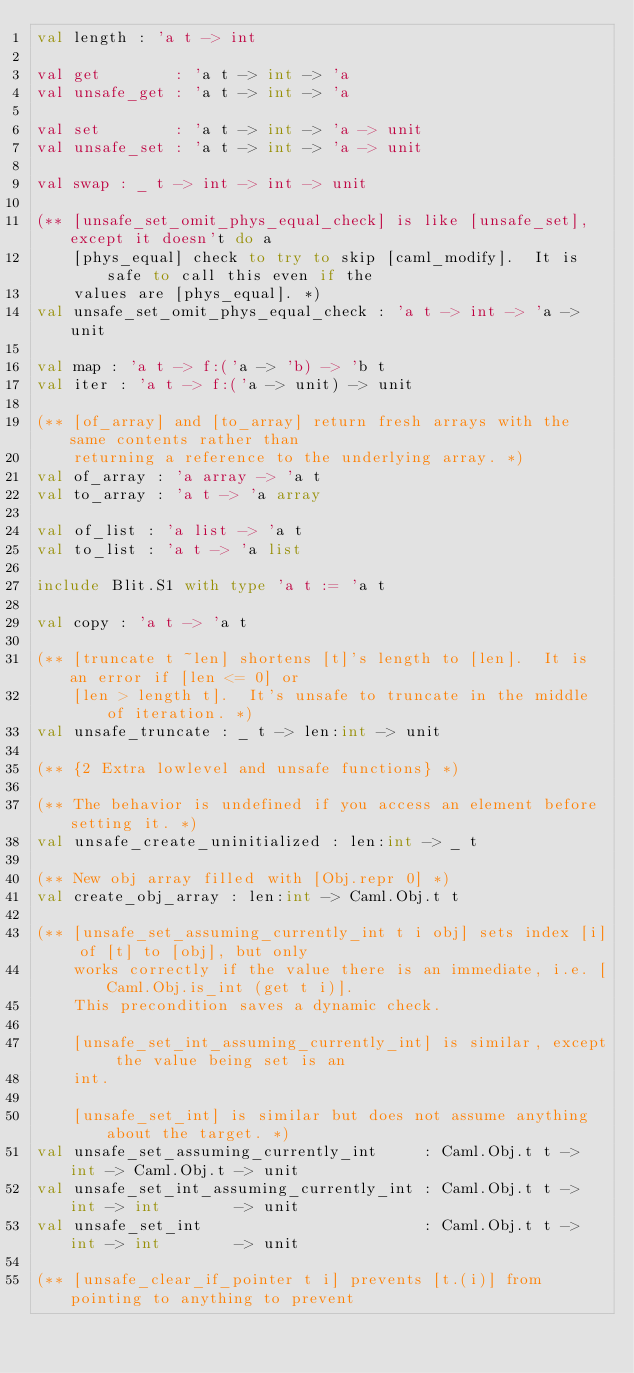<code> <loc_0><loc_0><loc_500><loc_500><_OCaml_>val length : 'a t -> int

val get        : 'a t -> int -> 'a
val unsafe_get : 'a t -> int -> 'a

val set        : 'a t -> int -> 'a -> unit
val unsafe_set : 'a t -> int -> 'a -> unit

val swap : _ t -> int -> int -> unit

(** [unsafe_set_omit_phys_equal_check] is like [unsafe_set], except it doesn't do a
    [phys_equal] check to try to skip [caml_modify].  It is safe to call this even if the
    values are [phys_equal]. *)
val unsafe_set_omit_phys_equal_check : 'a t -> int -> 'a -> unit

val map : 'a t -> f:('a -> 'b) -> 'b t
val iter : 'a t -> f:('a -> unit) -> unit

(** [of_array] and [to_array] return fresh arrays with the same contents rather than
    returning a reference to the underlying array. *)
val of_array : 'a array -> 'a t
val to_array : 'a t -> 'a array

val of_list : 'a list -> 'a t
val to_list : 'a t -> 'a list

include Blit.S1 with type 'a t := 'a t

val copy : 'a t -> 'a t

(** [truncate t ~len] shortens [t]'s length to [len].  It is an error if [len <= 0] or
    [len > length t].  It's unsafe to truncate in the middle of iteration. *)
val unsafe_truncate : _ t -> len:int -> unit

(** {2 Extra lowlevel and unsafe functions} *)

(** The behavior is undefined if you access an element before setting it. *)
val unsafe_create_uninitialized : len:int -> _ t

(** New obj array filled with [Obj.repr 0] *)
val create_obj_array : len:int -> Caml.Obj.t t

(** [unsafe_set_assuming_currently_int t i obj] sets index [i] of [t] to [obj], but only
    works correctly if the value there is an immediate, i.e. [Caml.Obj.is_int (get t i)].
    This precondition saves a dynamic check.

    [unsafe_set_int_assuming_currently_int] is similar, except the value being set is an
    int.

    [unsafe_set_int] is similar but does not assume anything about the target. *)
val unsafe_set_assuming_currently_int     : Caml.Obj.t t -> int -> Caml.Obj.t -> unit
val unsafe_set_int_assuming_currently_int : Caml.Obj.t t -> int -> int        -> unit
val unsafe_set_int                        : Caml.Obj.t t -> int -> int        -> unit

(** [unsafe_clear_if_pointer t i] prevents [t.(i)] from pointing to anything to prevent</code> 